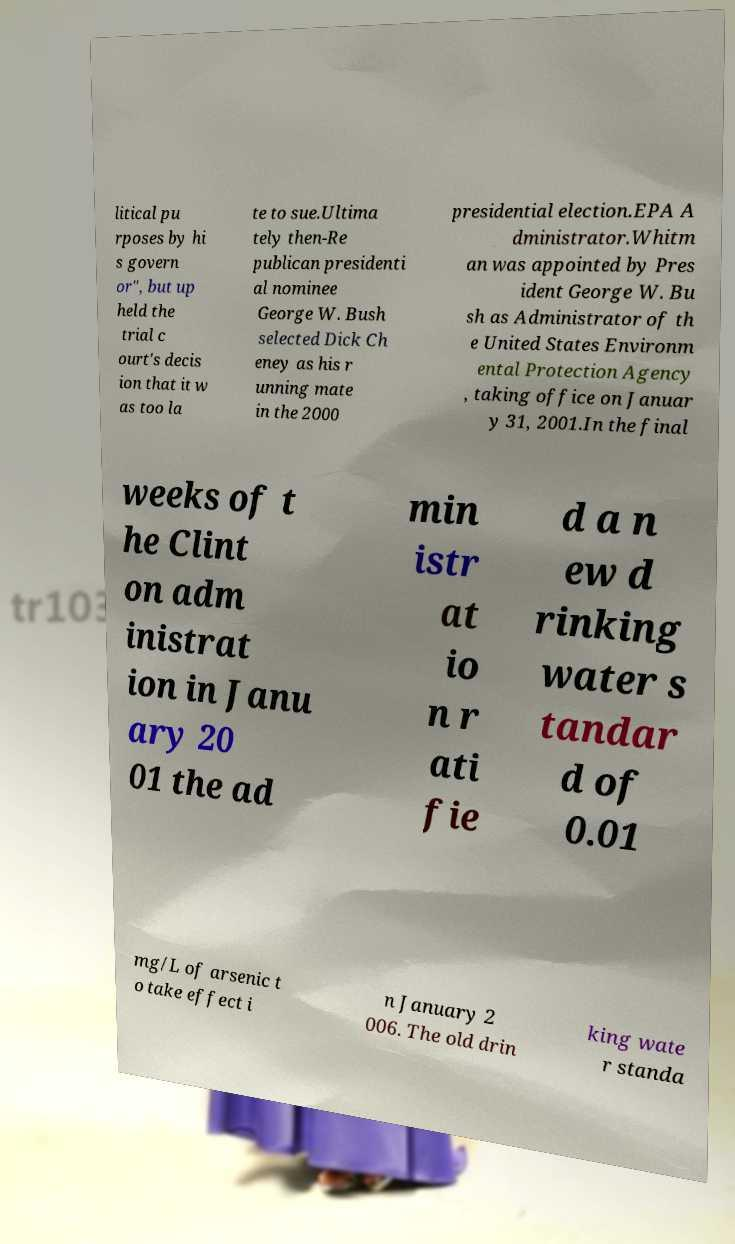Please read and relay the text visible in this image. What does it say? litical pu rposes by hi s govern or", but up held the trial c ourt's decis ion that it w as too la te to sue.Ultima tely then-Re publican presidenti al nominee George W. Bush selected Dick Ch eney as his r unning mate in the 2000 presidential election.EPA A dministrator.Whitm an was appointed by Pres ident George W. Bu sh as Administrator of th e United States Environm ental Protection Agency , taking office on Januar y 31, 2001.In the final weeks of t he Clint on adm inistrat ion in Janu ary 20 01 the ad min istr at io n r ati fie d a n ew d rinking water s tandar d of 0.01 mg/L of arsenic t o take effect i n January 2 006. The old drin king wate r standa 